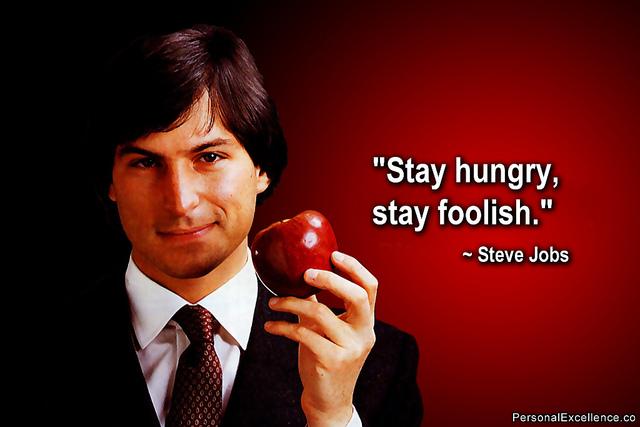Does this man have a smug look on his face?
Short answer required. Yes. What is the ad promoting?
Quick response, please. Apple. Is that a pear he is holding?
Concise answer only. No. 